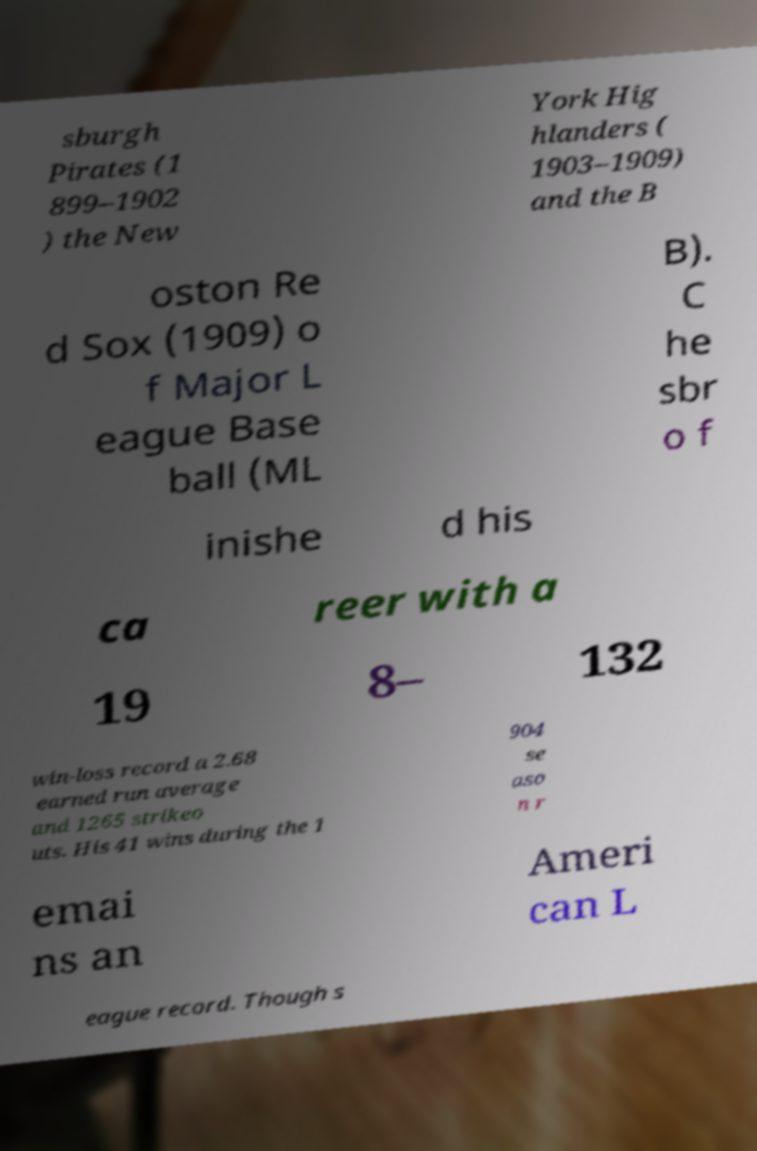Please identify and transcribe the text found in this image. sburgh Pirates (1 899–1902 ) the New York Hig hlanders ( 1903–1909) and the B oston Re d Sox (1909) o f Major L eague Base ball (ML B). C he sbr o f inishe d his ca reer with a 19 8– 132 win-loss record a 2.68 earned run average and 1265 strikeo uts. His 41 wins during the 1 904 se aso n r emai ns an Ameri can L eague record. Though s 